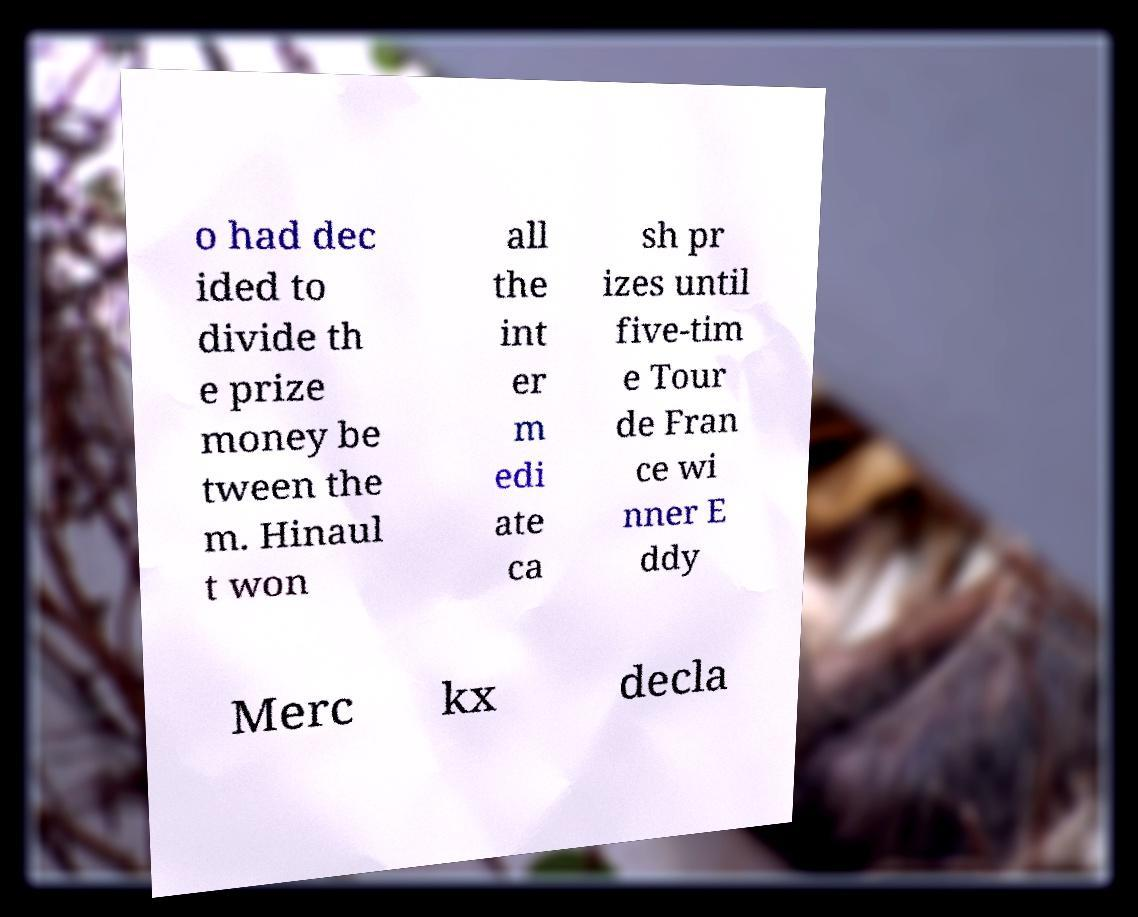Could you assist in decoding the text presented in this image and type it out clearly? o had dec ided to divide th e prize money be tween the m. Hinaul t won all the int er m edi ate ca sh pr izes until five-tim e Tour de Fran ce wi nner E ddy Merc kx decla 